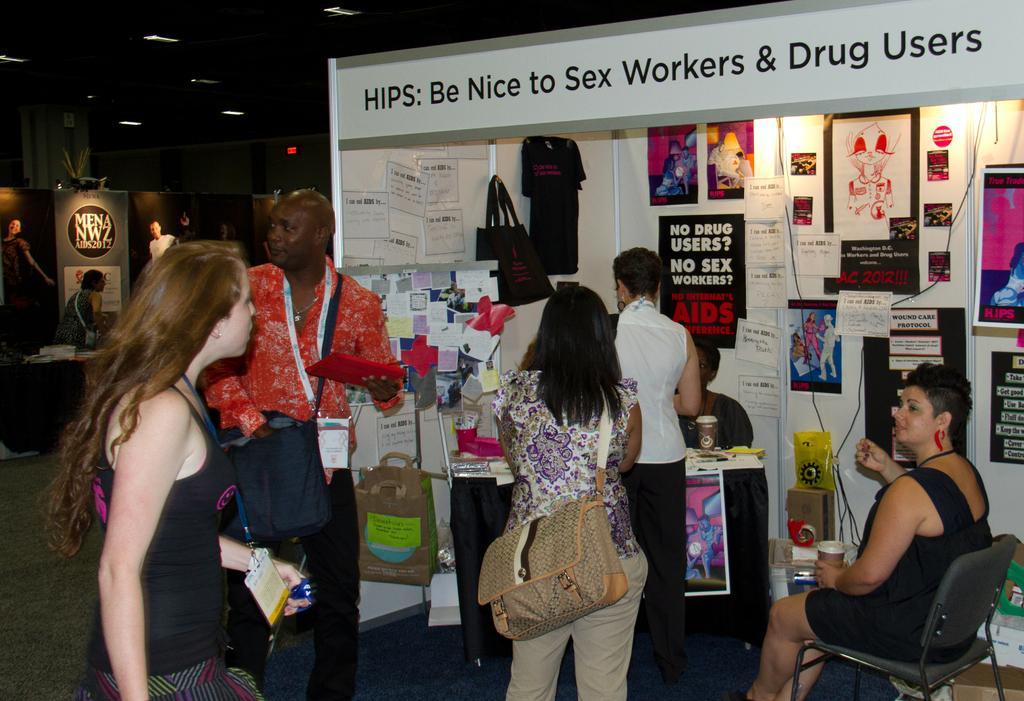How would you summarize this image in a sentence or two? In this image, we can see persons in front of the stall. There is an another person in front of the sponsor board. There are lights on the ceiling. 